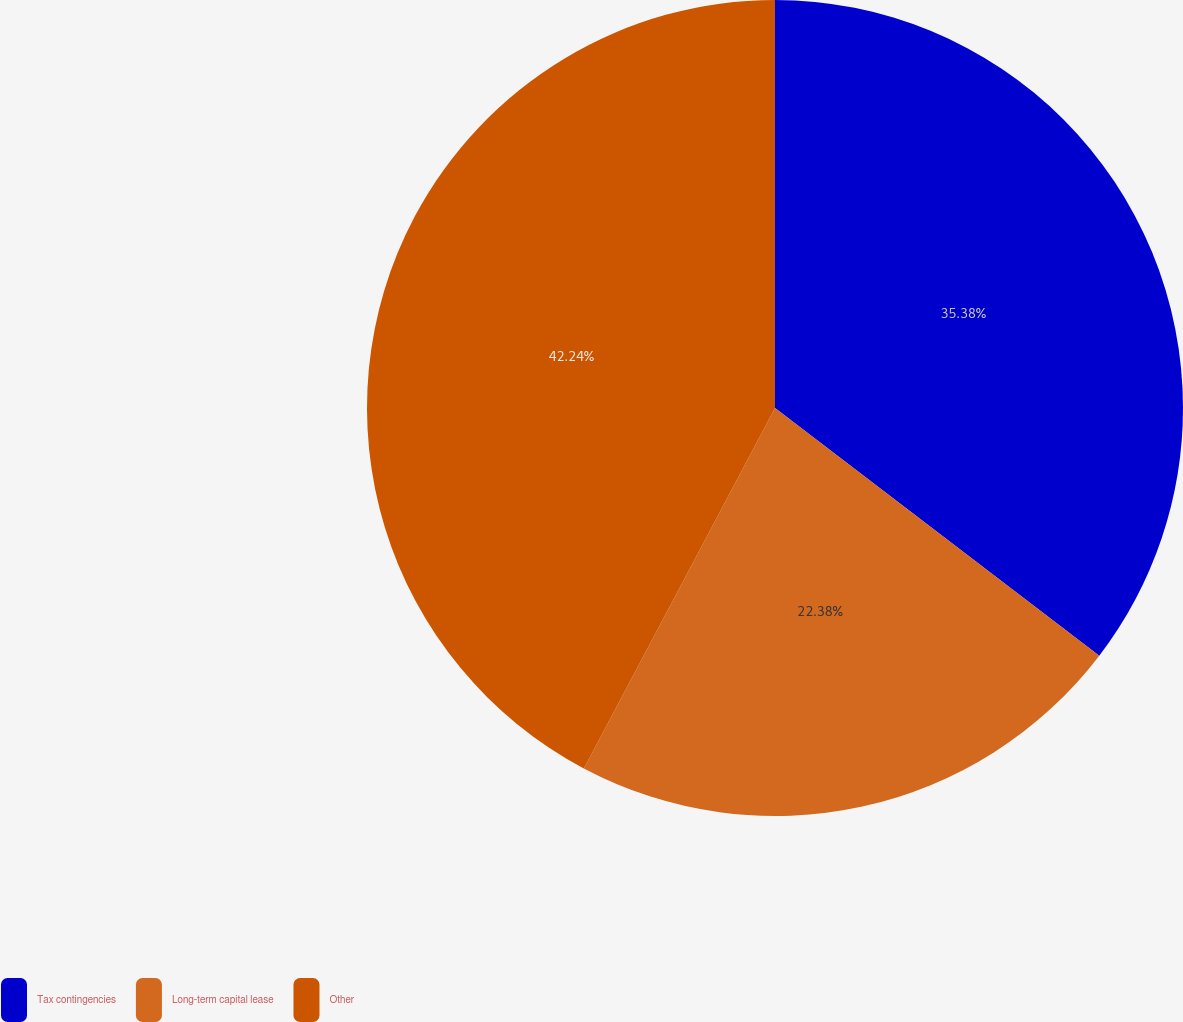Convert chart. <chart><loc_0><loc_0><loc_500><loc_500><pie_chart><fcel>Tax contingencies<fcel>Long-term capital lease<fcel>Other<nl><fcel>35.38%<fcel>22.38%<fcel>42.24%<nl></chart> 